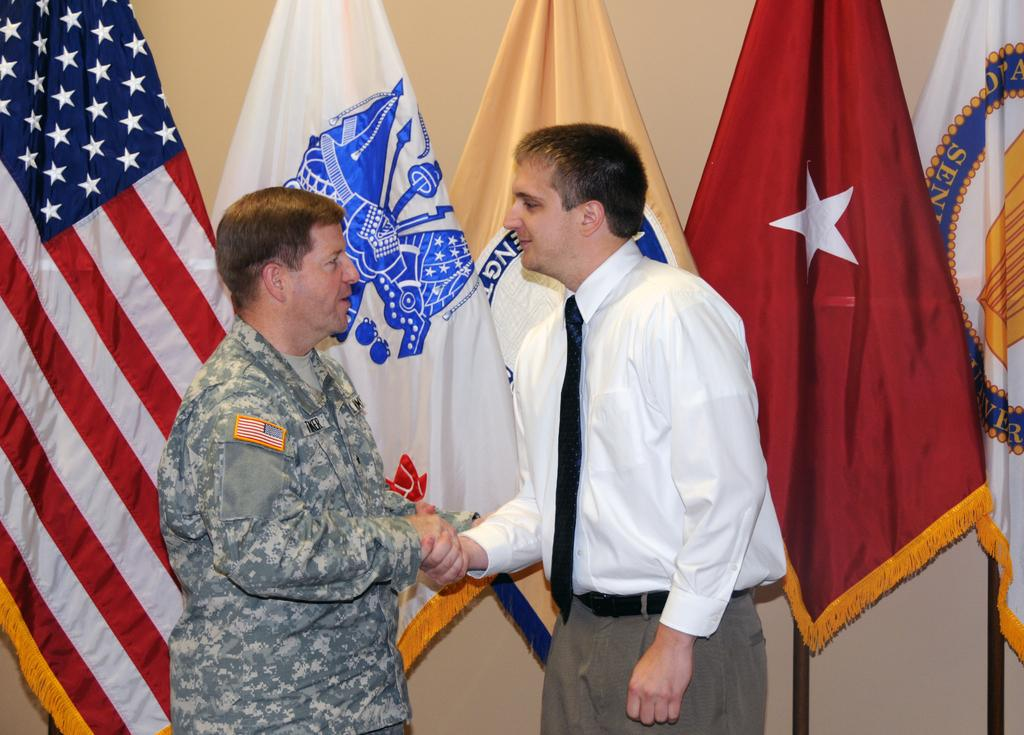How many people are in the image? There are two men standing in the image. What can be seen behind the men? There are poles with flags behind the men. What is visible in the background of the image? There is a wall in the background of the image. What type of bread is being used to stop the car in the image? There is no car or bread present in the image. Who is the uncle of the men in the image? There is no mention of an uncle in the image or the provided facts. 